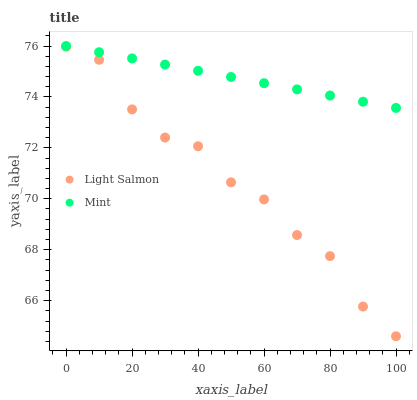Does Light Salmon have the minimum area under the curve?
Answer yes or no. Yes. Does Mint have the maximum area under the curve?
Answer yes or no. Yes. Does Mint have the minimum area under the curve?
Answer yes or no. No. Is Mint the smoothest?
Answer yes or no. Yes. Is Light Salmon the roughest?
Answer yes or no. Yes. Is Mint the roughest?
Answer yes or no. No. Does Light Salmon have the lowest value?
Answer yes or no. Yes. Does Mint have the lowest value?
Answer yes or no. No. Does Mint have the highest value?
Answer yes or no. Yes. Is Light Salmon less than Mint?
Answer yes or no. Yes. Is Mint greater than Light Salmon?
Answer yes or no. Yes. Does Light Salmon intersect Mint?
Answer yes or no. No. 